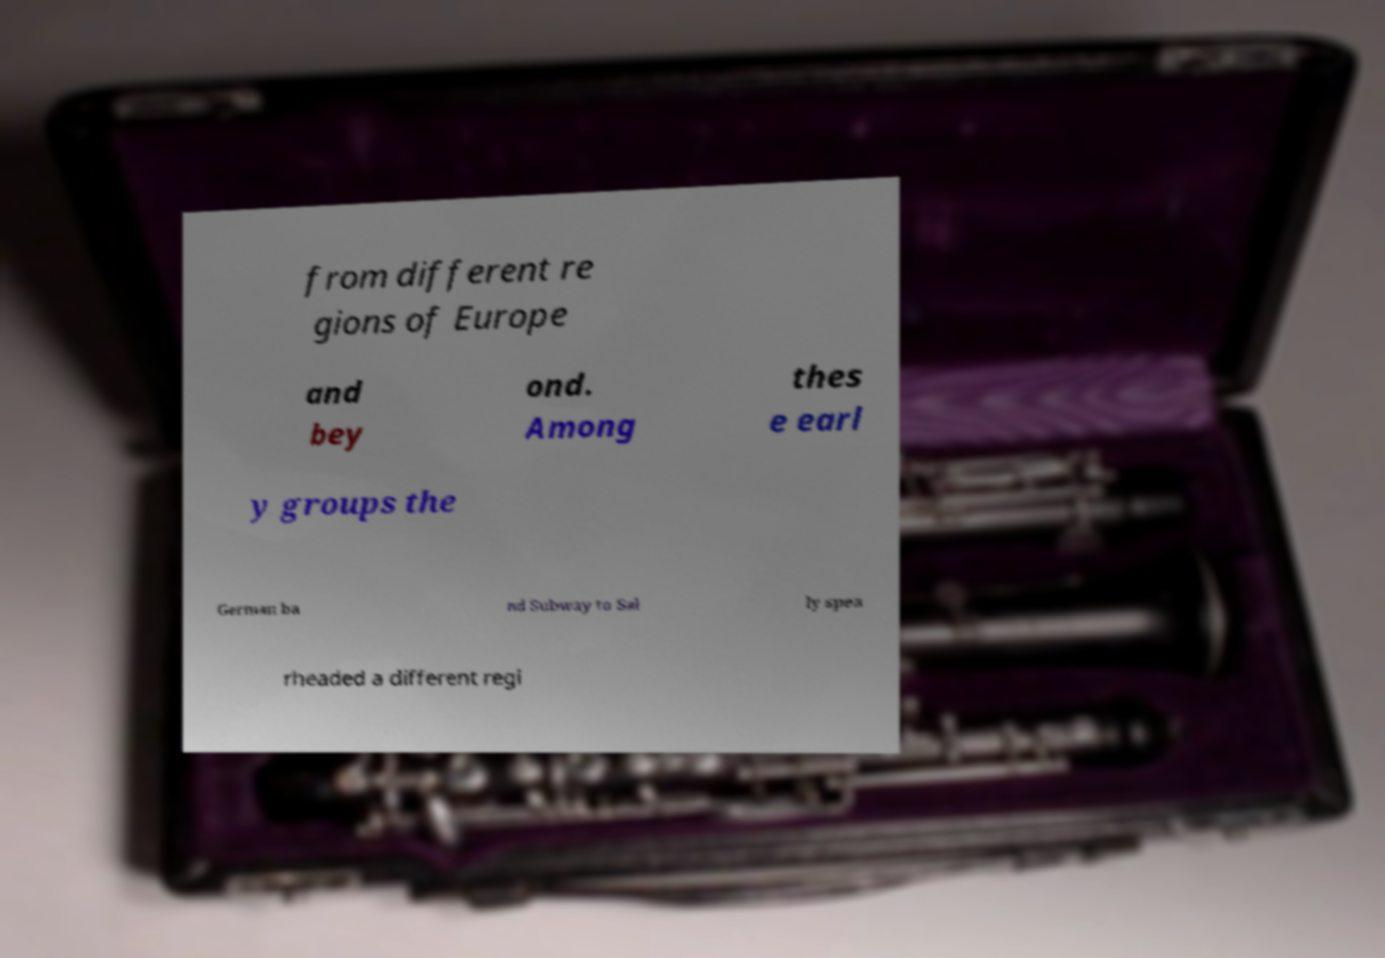Please identify and transcribe the text found in this image. from different re gions of Europe and bey ond. Among thes e earl y groups the German ba nd Subway to Sal ly spea rheaded a different regi 